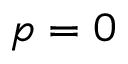<formula> <loc_0><loc_0><loc_500><loc_500>p = 0</formula> 